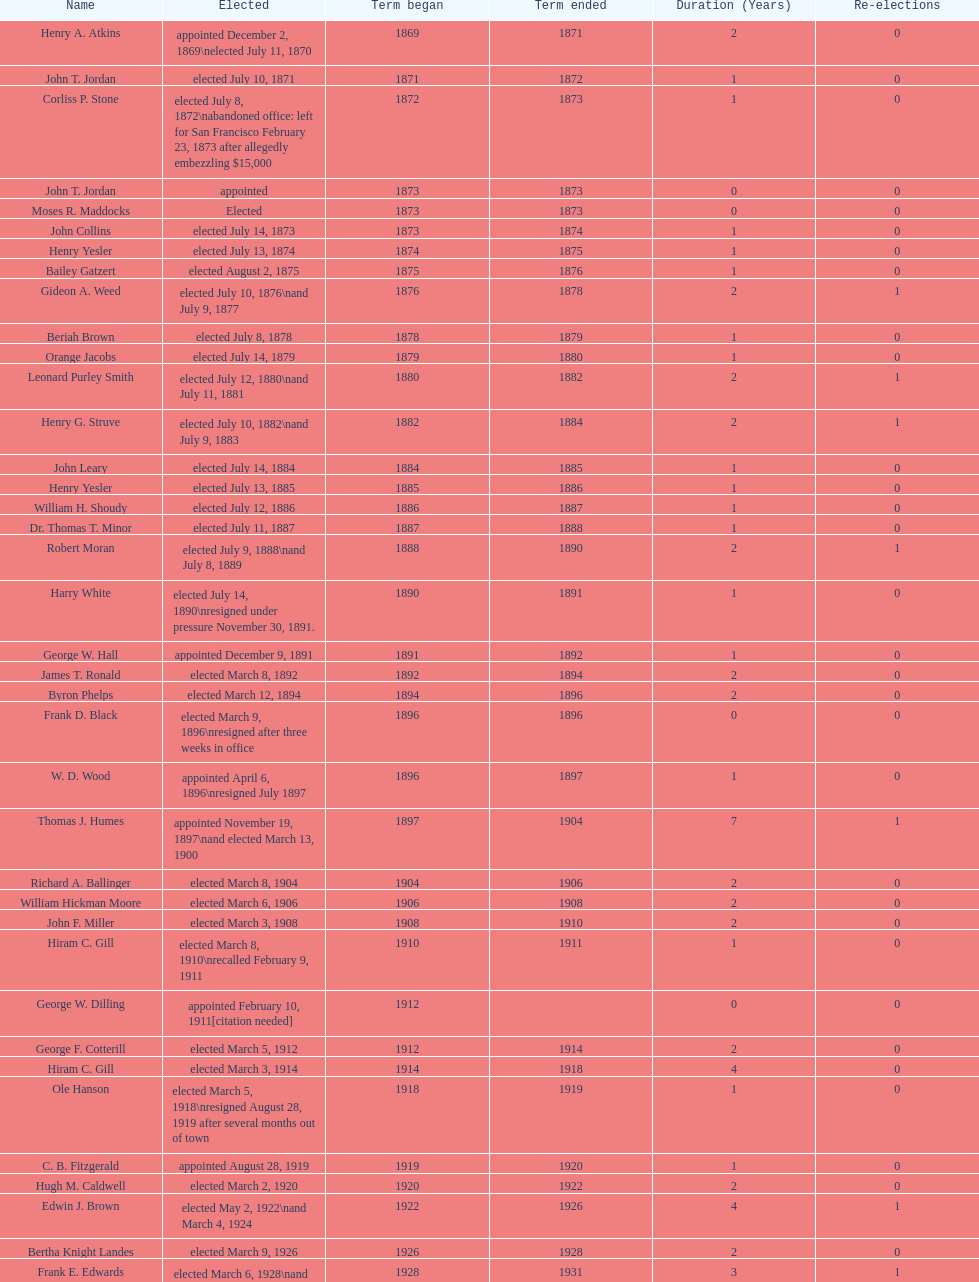Who was the first mayor in the 1900's? Richard A. Ballinger. Could you help me parse every detail presented in this table? {'header': ['Name', 'Elected', 'Term began', 'Term ended', 'Duration (Years)', 'Re-elections'], 'rows': [['Henry A. Atkins', 'appointed December 2, 1869\\nelected July 11, 1870', '1869', '1871', '2', '0'], ['John T. Jordan', 'elected July 10, 1871', '1871', '1872', '1', '0'], ['Corliss P. Stone', 'elected July 8, 1872\\nabandoned office: left for San Francisco February 23, 1873 after allegedly embezzling $15,000', '1872', '1873', '1', '0'], ['John T. Jordan', 'appointed', '1873', '1873', '0', '0'], ['Moses R. Maddocks', 'Elected', '1873', '1873', '0', '0'], ['John Collins', 'elected July 14, 1873', '1873', '1874', '1', '0'], ['Henry Yesler', 'elected July 13, 1874', '1874', '1875', '1', '0'], ['Bailey Gatzert', 'elected August 2, 1875', '1875', '1876', '1', '0'], ['Gideon A. Weed', 'elected July 10, 1876\\nand July 9, 1877', '1876', '1878', '2', '1'], ['Beriah Brown', 'elected July 8, 1878', '1878', '1879', '1', '0'], ['Orange Jacobs', 'elected July 14, 1879', '1879', '1880', '1', '0'], ['Leonard Purley Smith', 'elected July 12, 1880\\nand July 11, 1881', '1880', '1882', '2', '1'], ['Henry G. Struve', 'elected July 10, 1882\\nand July 9, 1883', '1882', '1884', '2', '1'], ['John Leary', 'elected July 14, 1884', '1884', '1885', '1', '0'], ['Henry Yesler', 'elected July 13, 1885', '1885', '1886', '1', '0'], ['William H. Shoudy', 'elected July 12, 1886', '1886', '1887', '1', '0'], ['Dr. Thomas T. Minor', 'elected July 11, 1887', '1887', '1888', '1', '0'], ['Robert Moran', 'elected July 9, 1888\\nand July 8, 1889', '1888', '1890', '2', '1'], ['Harry White', 'elected July 14, 1890\\nresigned under pressure November 30, 1891.', '1890', '1891', '1', '0'], ['George W. Hall', 'appointed December 9, 1891', '1891', '1892', '1', '0'], ['James T. Ronald', 'elected March 8, 1892', '1892', '1894', '2', '0'], ['Byron Phelps', 'elected March 12, 1894', '1894', '1896', '2', '0'], ['Frank D. Black', 'elected March 9, 1896\\nresigned after three weeks in office', '1896', '1896', '0', '0'], ['W. D. Wood', 'appointed April 6, 1896\\nresigned July 1897', '1896', '1897', '1', '0'], ['Thomas J. Humes', 'appointed November 19, 1897\\nand elected March 13, 1900', '1897', '1904', '7', '1'], ['Richard A. Ballinger', 'elected March 8, 1904', '1904', '1906', '2', '0'], ['William Hickman Moore', 'elected March 6, 1906', '1906', '1908', '2', '0'], ['John F. Miller', 'elected March 3, 1908', '1908', '1910', '2', '0'], ['Hiram C. Gill', 'elected March 8, 1910\\nrecalled February 9, 1911', '1910', '1911', '1', '0'], ['George W. Dilling', 'appointed February 10, 1911[citation needed]', '1912', '', '0', '0'], ['George F. Cotterill', 'elected March 5, 1912', '1912', '1914', '2', '0'], ['Hiram C. Gill', 'elected March 3, 1914', '1914', '1918', '4', '0'], ['Ole Hanson', 'elected March 5, 1918\\nresigned August 28, 1919 after several months out of town', '1918', '1919', '1', '0'], ['C. B. Fitzgerald', 'appointed August 28, 1919', '1919', '1920', '1', '0'], ['Hugh M. Caldwell', 'elected March 2, 1920', '1920', '1922', '2', '0'], ['Edwin J. Brown', 'elected May 2, 1922\\nand March 4, 1924', '1922', '1926', '4', '1'], ['Bertha Knight Landes', 'elected March 9, 1926', '1926', '1928', '2', '0'], ['Frank E. Edwards', 'elected March 6, 1928\\nand March 4, 1930\\nrecalled July 13, 1931', '1928', '1931', '3', '1'], ['Robert H. Harlin', 'appointed July 14, 1931', '1931', '1932', '1', '0'], ['John F. Dore', 'elected March 8, 1932', '1932', '1934', '2', '0'], ['Charles L. Smith', 'elected March 6, 1934', '1934', '1936', '2', '0'], ['John F. Dore', 'elected March 3, 1936\\nbecame gravely ill and was relieved of office April 13, 1938, already a lame duck after the 1938 election. He died five days later.', '1936', '1938', '2', '0'], ['Arthur B. Langlie', "elected March 8, 1938\\nappointed to take office early, April 27, 1938, after Dore's death.\\nelected March 5, 1940\\nresigned January 11, 1941, to become Governor of Washington", '1938', '1941', '3', '1'], ['John E. Carroll', 'appointed January 27, 1941', '1941', '1941', '0', '0'], ['Earl Millikin', 'elected March 4, 1941', '1941', '1942', '1', '0'], ['William F. Devin', 'elected March 3, 1942, March 7, 1944, March 5, 1946, and March 2, 1948', '1942', '1952', '10', '3'], ['Allan Pomeroy', 'elected March 4, 1952', '1952', '1956', '4', '0'], ['Gordon S. Clinton', 'elected March 6, 1956\\nand March 8, 1960', '1956', '1964', '8', '1'], ["James d'Orma Braman", 'elected March 10, 1964\\nresigned March 23, 1969, to accept an appointment as an Assistant Secretary in the Department of Transportation in the Nixon administration.', '1964', '1969', '5', '0'], ['Floyd C. Miller', 'appointed March 23, 1969', '1969', '1969', '0', '0'], ['Wesley C. Uhlman', 'elected November 4, 1969\\nand November 6, 1973\\nsurvived recall attempt on July 1, 1975', 'December 1, 1969', 'January 1, 1978', '9', '1'], ['Charles Royer', 'elected November 8, 1977, November 3, 1981, and November 5, 1985', 'January 1, 1978', 'January 1, 1990', '12', '2'], ['Norman B. Rice', 'elected November 7, 1989', 'January 1, 1990', 'January 1, 1998', '8', '0'], ['Paul Schell', 'elected November 4, 1997', 'January 1, 1998', 'January 1, 2002', '4', '0'], ['Gregory J. Nickels', 'elected November 6, 2001\\nand November 8, 2005', 'January 1, 2002', 'January 1, 2010', '8', '1'], ['Michael McGinn', 'elected November 3, 2009', 'January 1, 2010', 'January 1, 2014', '4', '0'], ['Ed Murray', 'elected November 5, 2013', 'January 1, 2014', 'present', '-', '-']]} 